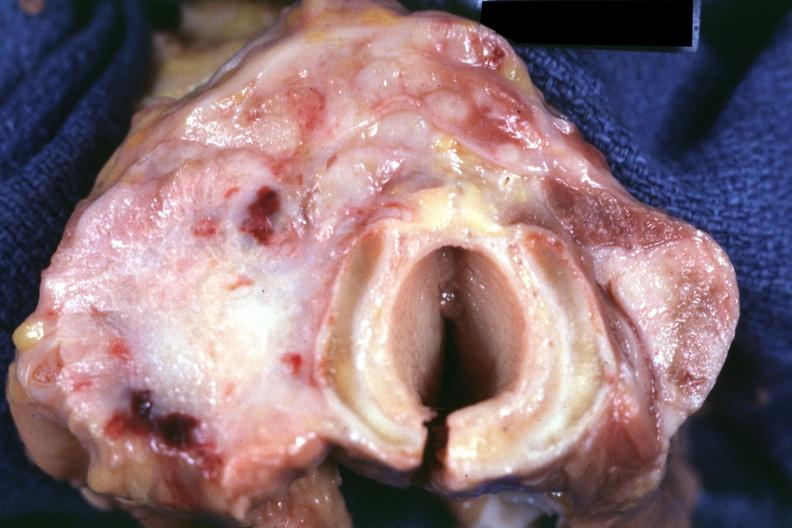what is present?
Answer the question using a single word or phrase. Carcinoma 